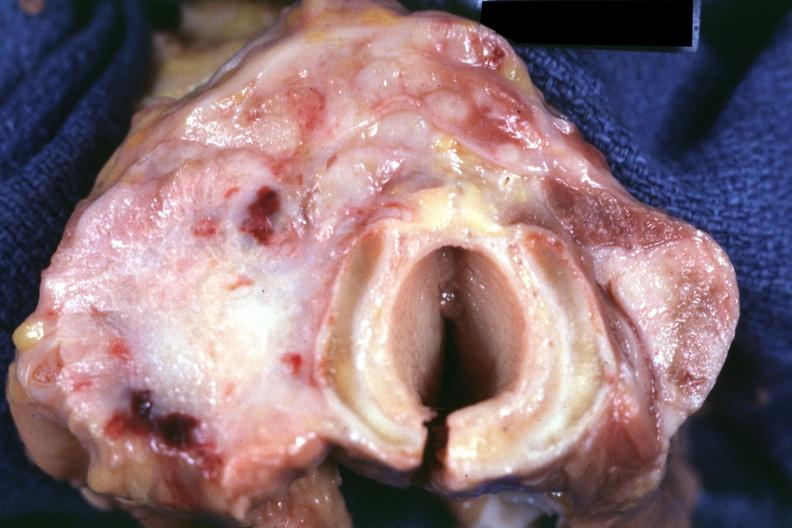what is present?
Answer the question using a single word or phrase. Carcinoma 